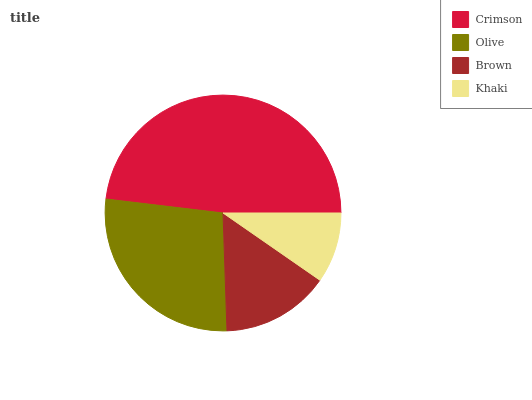Is Khaki the minimum?
Answer yes or no. Yes. Is Crimson the maximum?
Answer yes or no. Yes. Is Olive the minimum?
Answer yes or no. No. Is Olive the maximum?
Answer yes or no. No. Is Crimson greater than Olive?
Answer yes or no. Yes. Is Olive less than Crimson?
Answer yes or no. Yes. Is Olive greater than Crimson?
Answer yes or no. No. Is Crimson less than Olive?
Answer yes or no. No. Is Olive the high median?
Answer yes or no. Yes. Is Brown the low median?
Answer yes or no. Yes. Is Brown the high median?
Answer yes or no. No. Is Olive the low median?
Answer yes or no. No. 